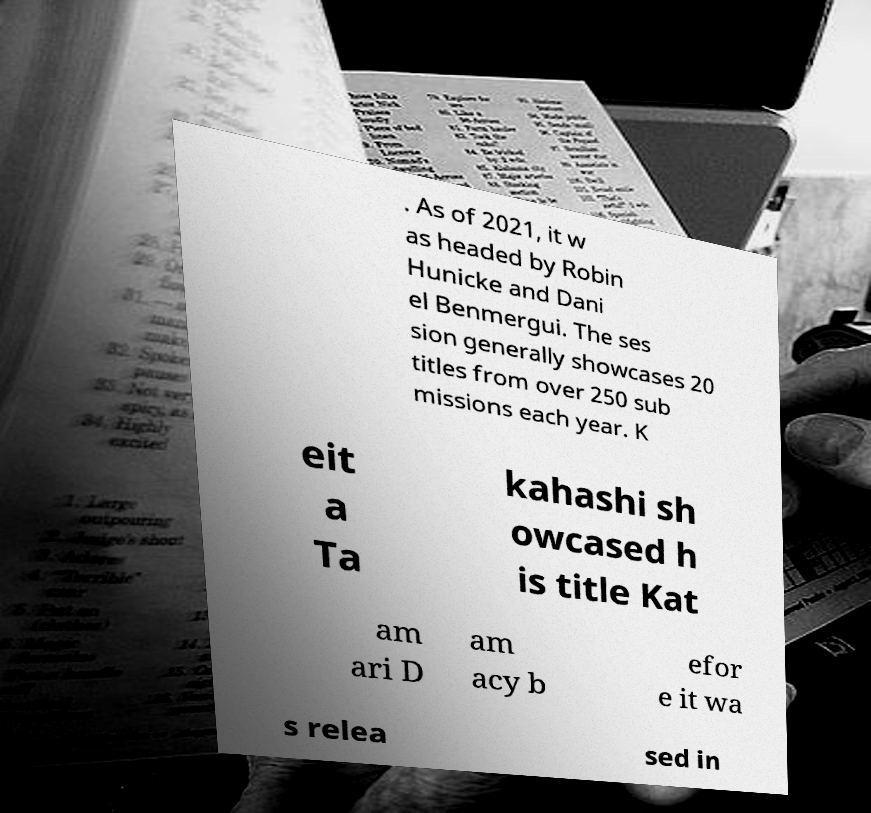Can you accurately transcribe the text from the provided image for me? . As of 2021, it w as headed by Robin Hunicke and Dani el Benmergui. The ses sion generally showcases 20 titles from over 250 sub missions each year. K eit a Ta kahashi sh owcased h is title Kat am ari D am acy b efor e it wa s relea sed in 